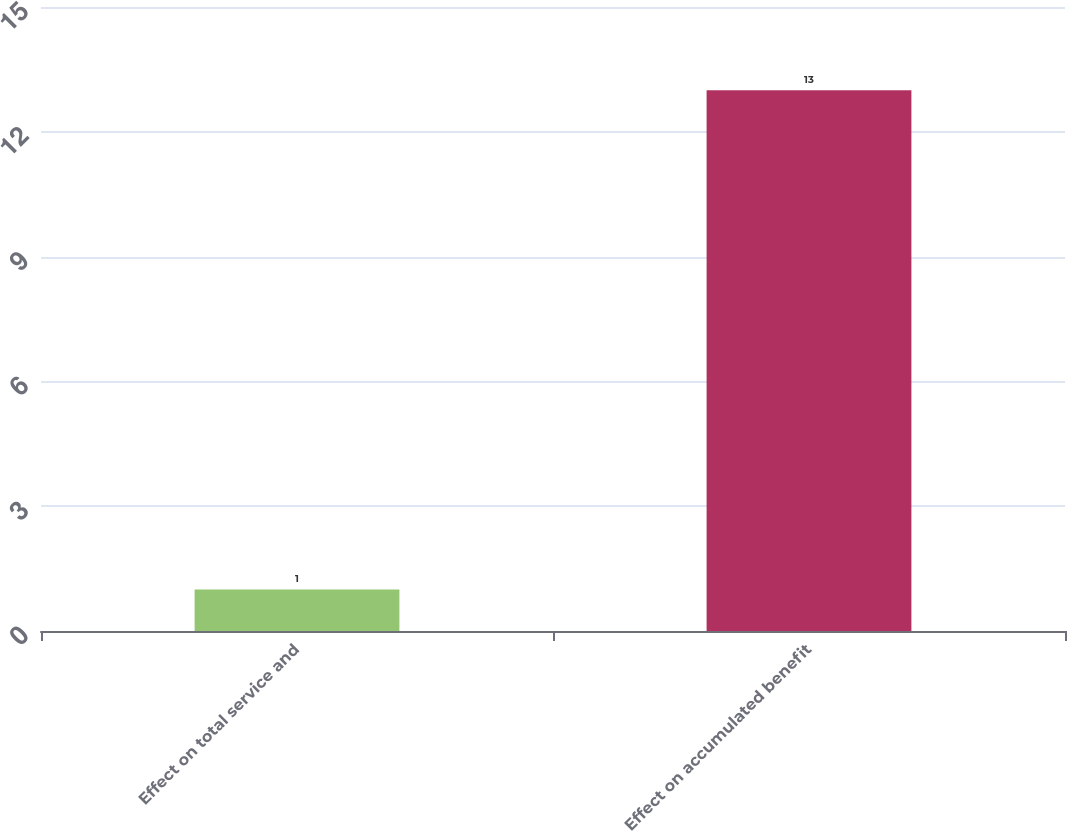Convert chart. <chart><loc_0><loc_0><loc_500><loc_500><bar_chart><fcel>Effect on total service and<fcel>Effect on accumulated benefit<nl><fcel>1<fcel>13<nl></chart> 